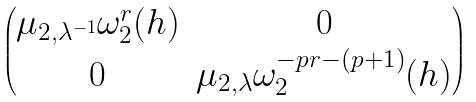<formula> <loc_0><loc_0><loc_500><loc_500>\begin{pmatrix} \mu _ { 2 , \lambda ^ { - 1 } } \omega _ { 2 } ^ { r } ( h ) & 0 \\ 0 & \mu _ { 2 , \lambda } \omega _ { 2 } ^ { - p r - ( p + 1 ) } ( h ) \end{pmatrix}</formula> 